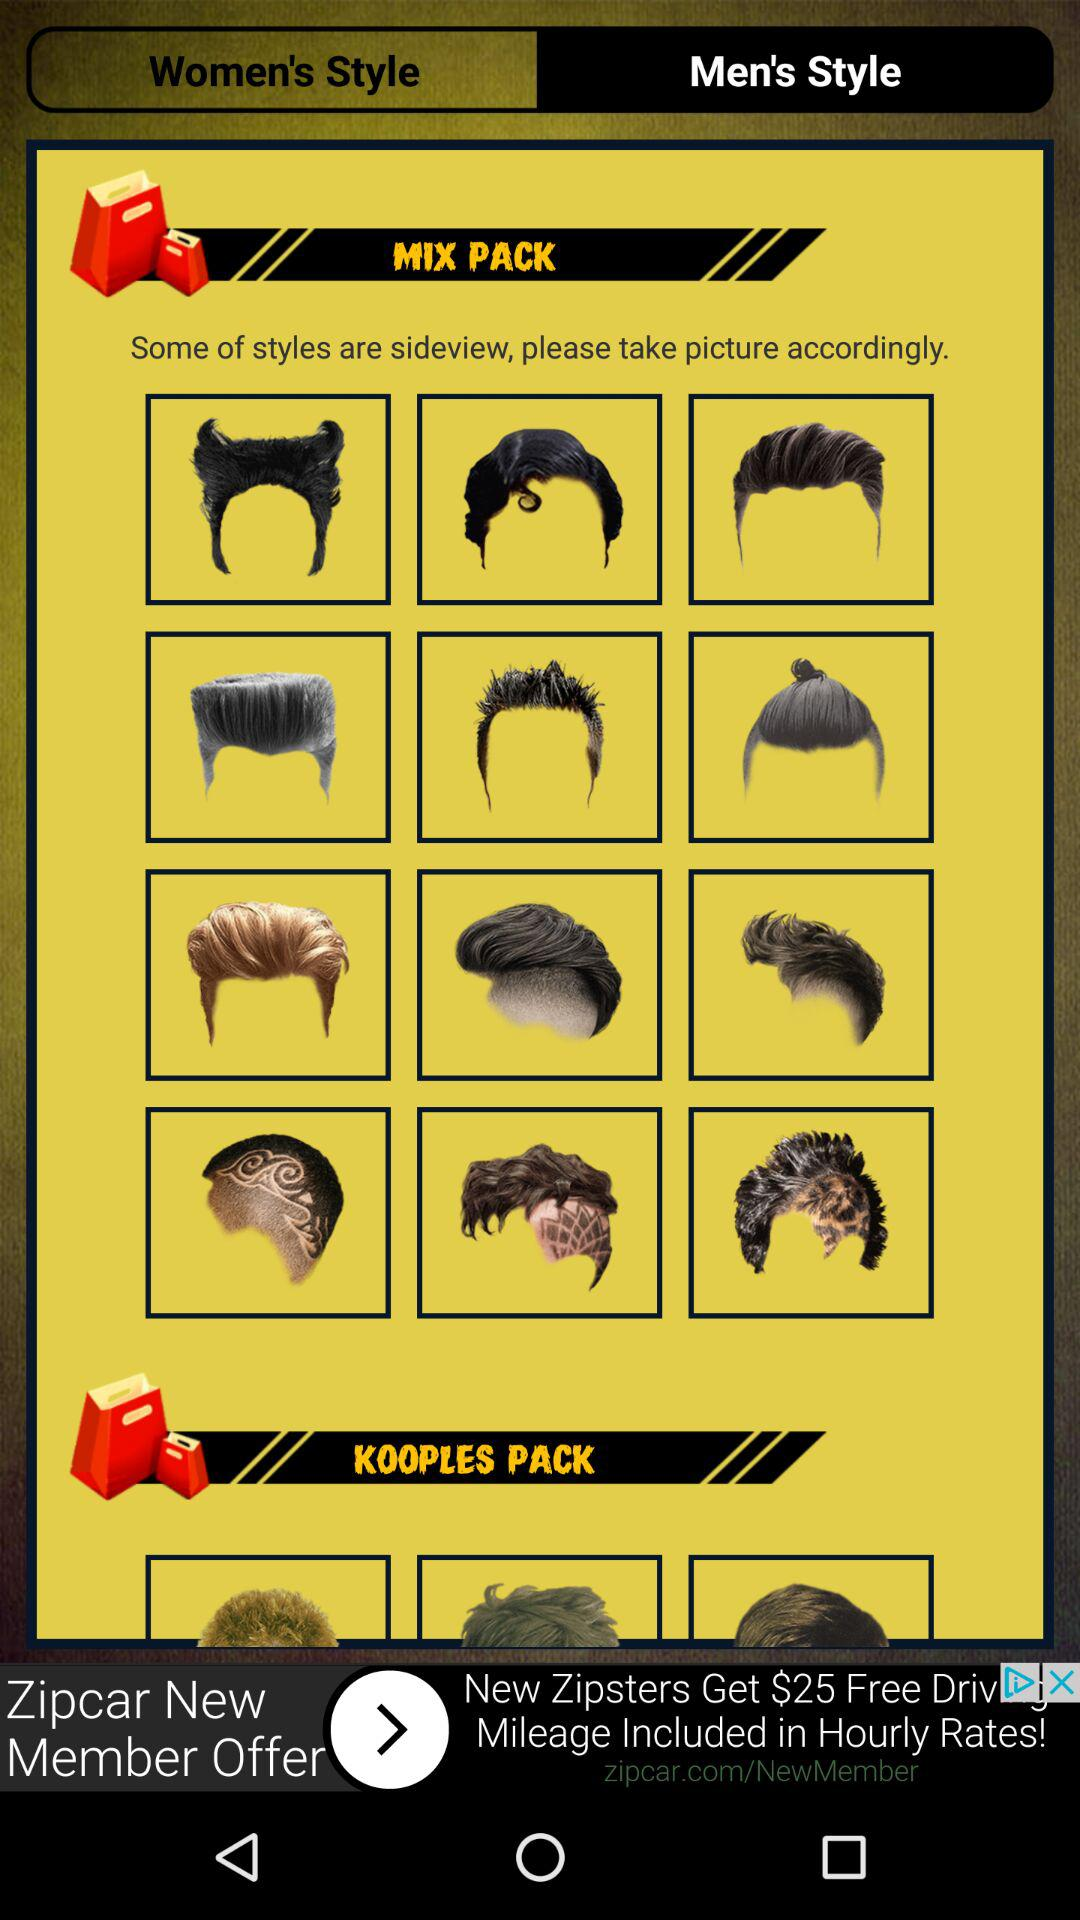Which tab is selected? The selected tab is "Men's Style". 